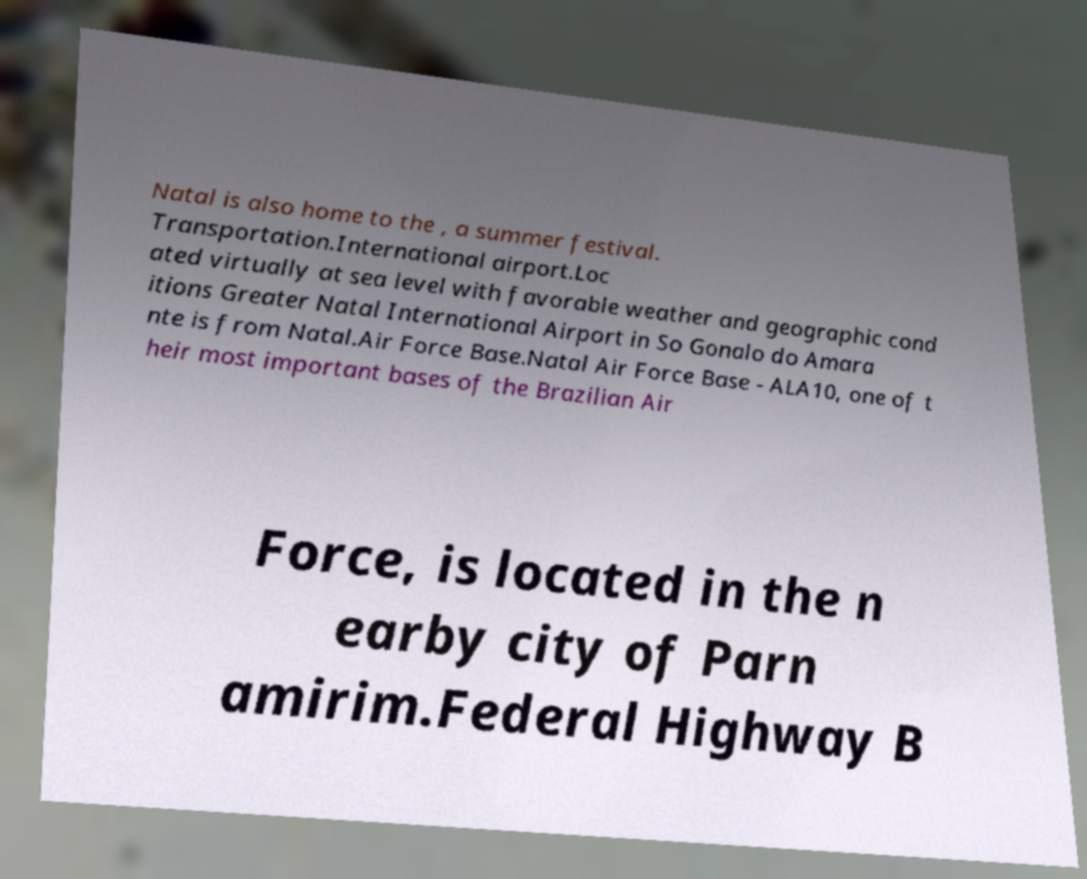Could you extract and type out the text from this image? Natal is also home to the , a summer festival. Transportation.International airport.Loc ated virtually at sea level with favorable weather and geographic cond itions Greater Natal International Airport in So Gonalo do Amara nte is from Natal.Air Force Base.Natal Air Force Base - ALA10, one of t heir most important bases of the Brazilian Air Force, is located in the n earby city of Parn amirim.Federal Highway B 